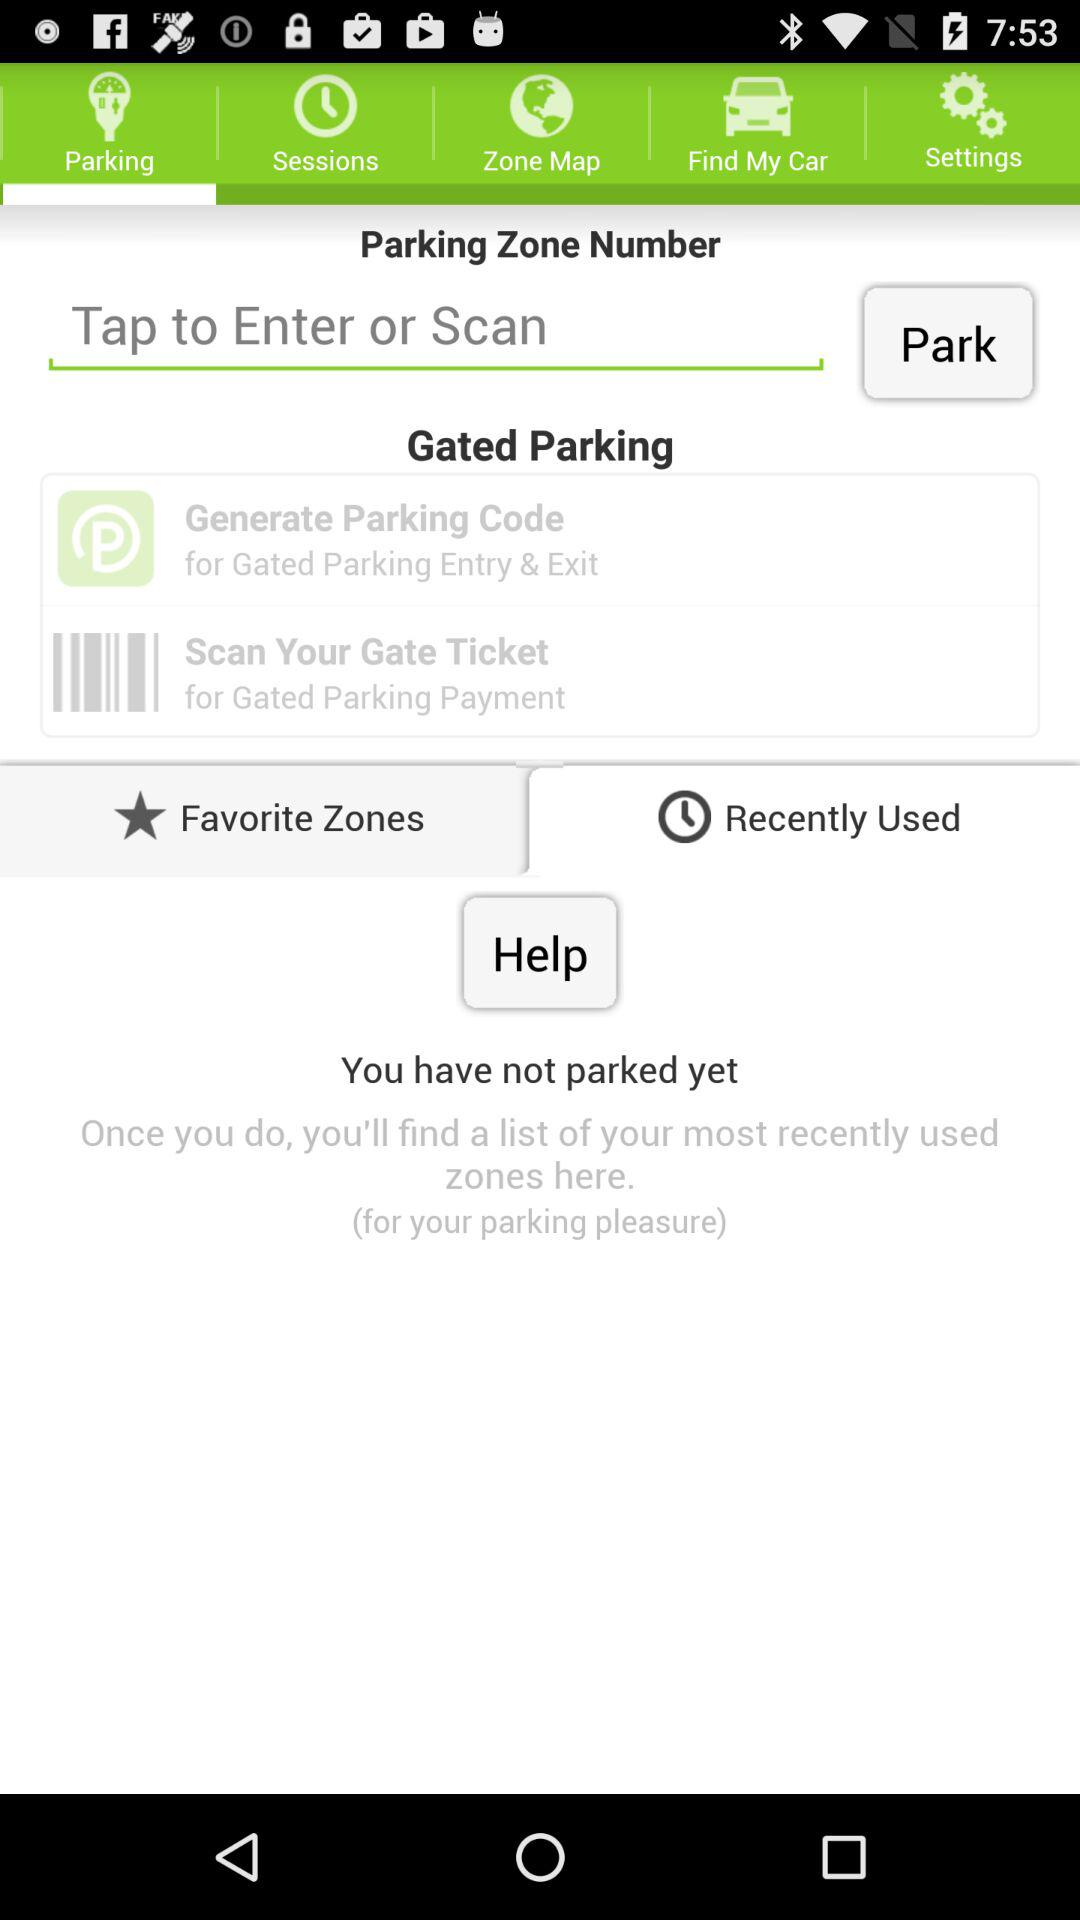What is the selected library?
When the provided information is insufficient, respond with <no answer>. <no answer> 